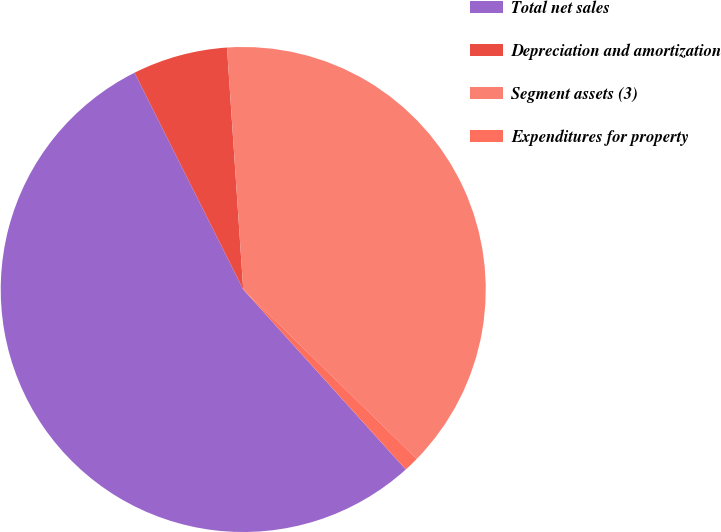Convert chart to OTSL. <chart><loc_0><loc_0><loc_500><loc_500><pie_chart><fcel>Total net sales<fcel>Depreciation and amortization<fcel>Segment assets (3)<fcel>Expenditures for property<nl><fcel>54.3%<fcel>6.33%<fcel>38.38%<fcel>1.0%<nl></chart> 